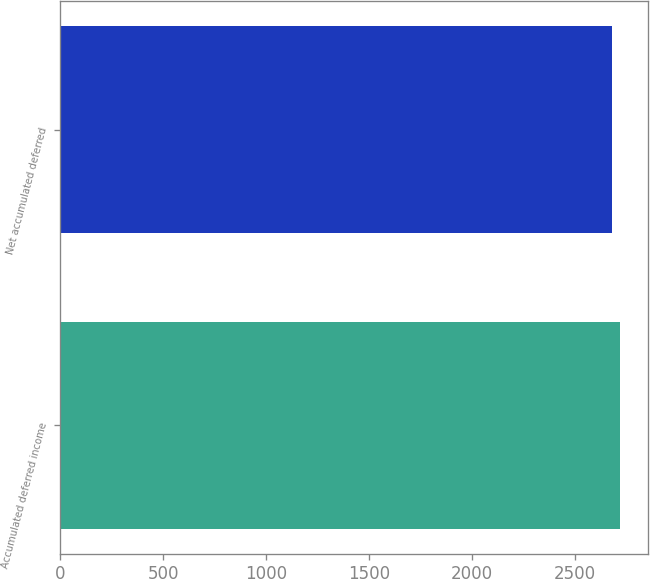<chart> <loc_0><loc_0><loc_500><loc_500><bar_chart><fcel>Accumulated deferred income<fcel>Net accumulated deferred<nl><fcel>2716<fcel>2679<nl></chart> 